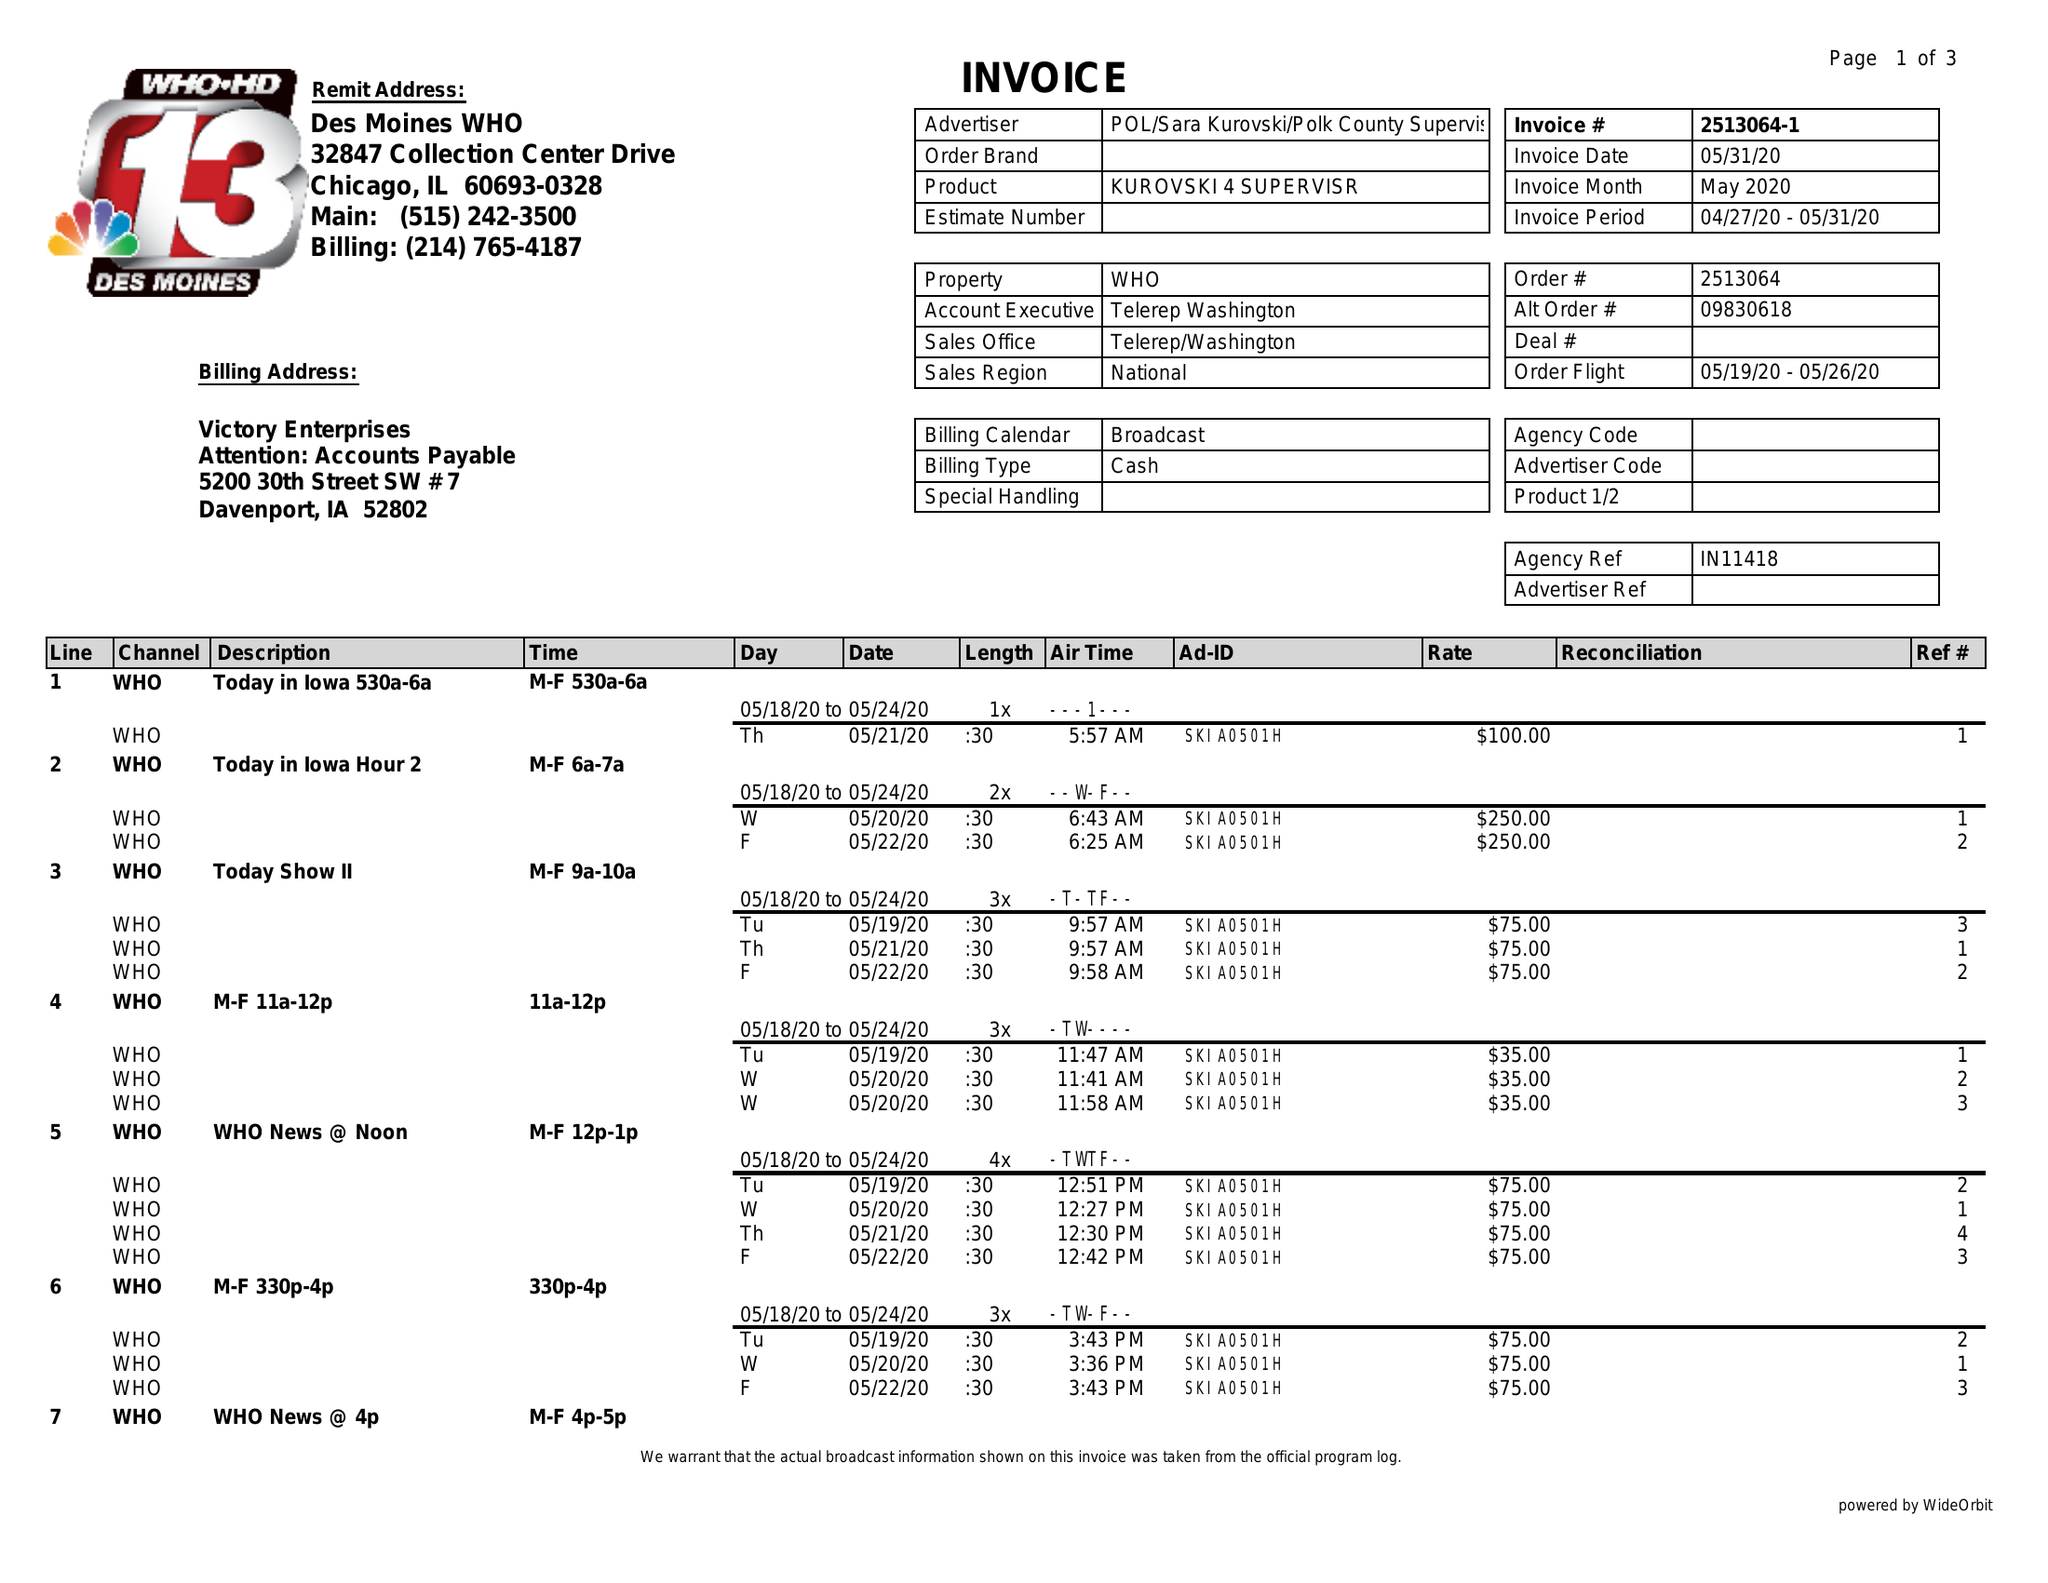What is the value for the flight_from?
Answer the question using a single word or phrase. 05/19/20 